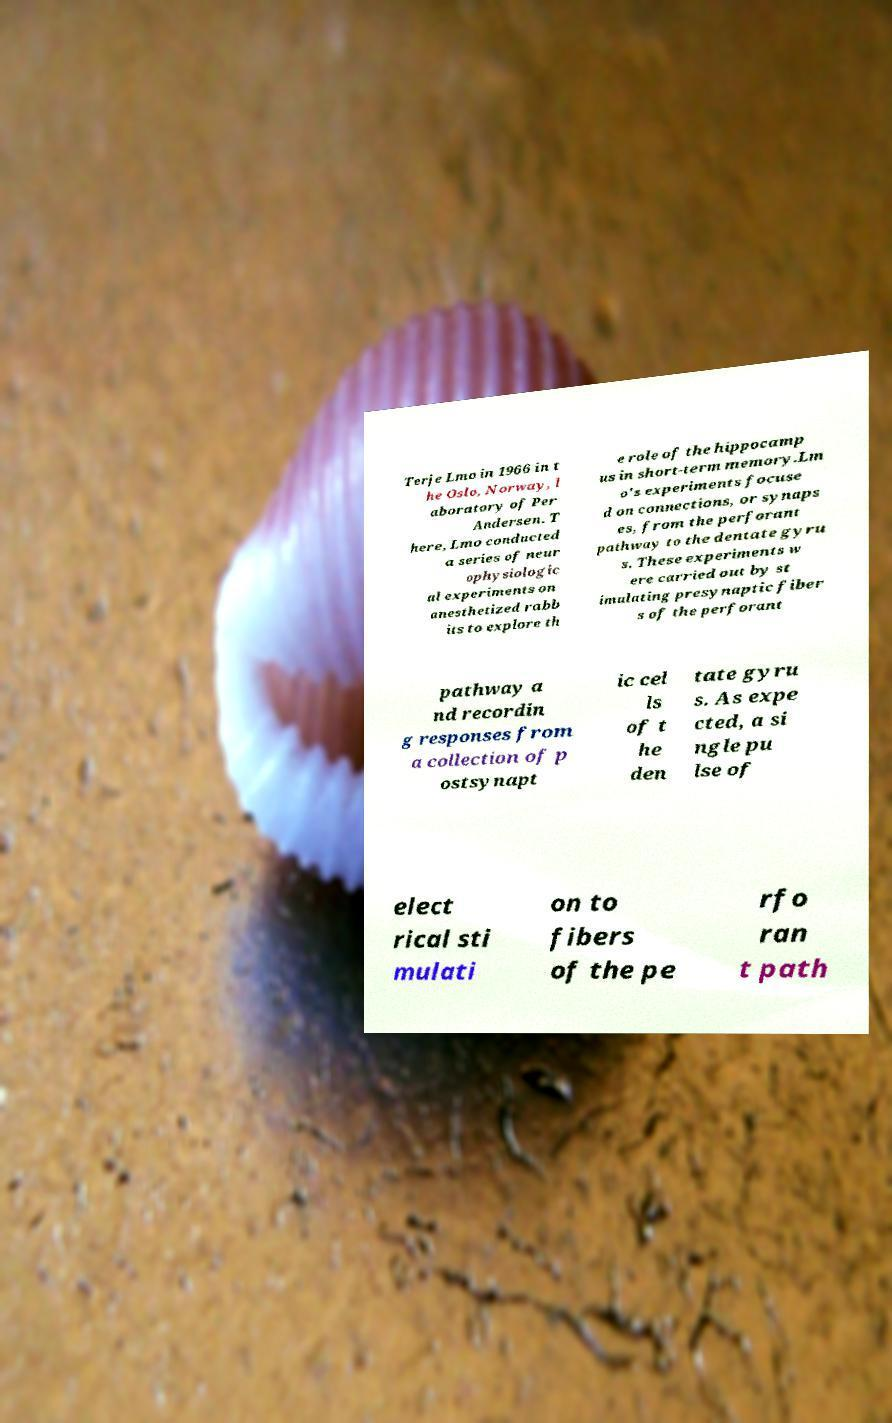Please read and relay the text visible in this image. What does it say? Terje Lmo in 1966 in t he Oslo, Norway, l aboratory of Per Andersen. T here, Lmo conducted a series of neur ophysiologic al experiments on anesthetized rabb its to explore th e role of the hippocamp us in short-term memory.Lm o's experiments focuse d on connections, or synaps es, from the perforant pathway to the dentate gyru s. These experiments w ere carried out by st imulating presynaptic fiber s of the perforant pathway a nd recordin g responses from a collection of p ostsynapt ic cel ls of t he den tate gyru s. As expe cted, a si ngle pu lse of elect rical sti mulati on to fibers of the pe rfo ran t path 